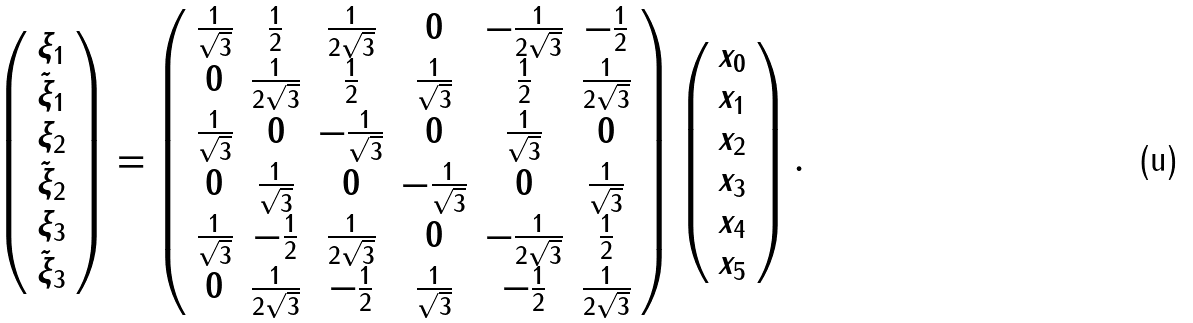Convert formula to latex. <formula><loc_0><loc_0><loc_500><loc_500>\left ( \begin{array} { c } \xi _ { 1 } \\ \tilde { \xi } _ { 1 } \\ \xi _ { 2 } \\ \tilde { \xi } _ { 2 } \\ \xi _ { 3 } \\ \tilde { \xi } _ { 3 } \\ \end{array} \right ) = \left ( \begin{array} { c c c c c c } \frac { 1 } { \sqrt { 3 } } & \frac { 1 } { 2 } & \frac { 1 } { 2 \sqrt { 3 } } & 0 & - \frac { 1 } { 2 \sqrt { 3 } } & - \frac { 1 } { 2 } \\ 0 & \frac { 1 } { 2 \sqrt { 3 } } & \frac { 1 } { 2 } & \frac { 1 } { \sqrt { 3 } } & \frac { 1 } { 2 } & \frac { 1 } { 2 \sqrt { 3 } } \\ \frac { 1 } { \sqrt { 3 } } & 0 & - \frac { 1 } { \sqrt { 3 } } & 0 & \frac { 1 } { \sqrt { 3 } } & 0 \\ 0 & \frac { 1 } { \sqrt { 3 } } & 0 & - \frac { 1 } { \sqrt { 3 } } & 0 & \frac { 1 } { \sqrt { 3 } } \\ \frac { 1 } { \sqrt { 3 } } & - \frac { 1 } { 2 } & \frac { 1 } { 2 \sqrt { 3 } } & 0 & - \frac { 1 } { 2 \sqrt { 3 } } & \frac { 1 } { 2 } \\ 0 & \frac { 1 } { 2 \sqrt { 3 } } & - \frac { 1 } { 2 } & \frac { 1 } { \sqrt { 3 } } & - \frac { 1 } { 2 } & \frac { 1 } { 2 \sqrt { 3 } } \\ \end{array} \right ) \left ( \begin{array} { c } x _ { 0 } \\ x _ { 1 } \\ x _ { 2 } \\ x _ { 3 } \\ x _ { 4 } \\ x _ { 5 } \end{array} \right ) .</formula> 